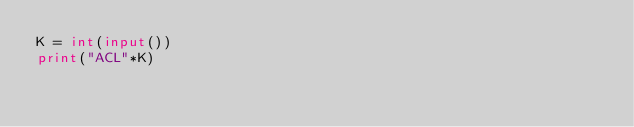Convert code to text. <code><loc_0><loc_0><loc_500><loc_500><_Python_>K = int(input())
print("ACL"*K)</code> 